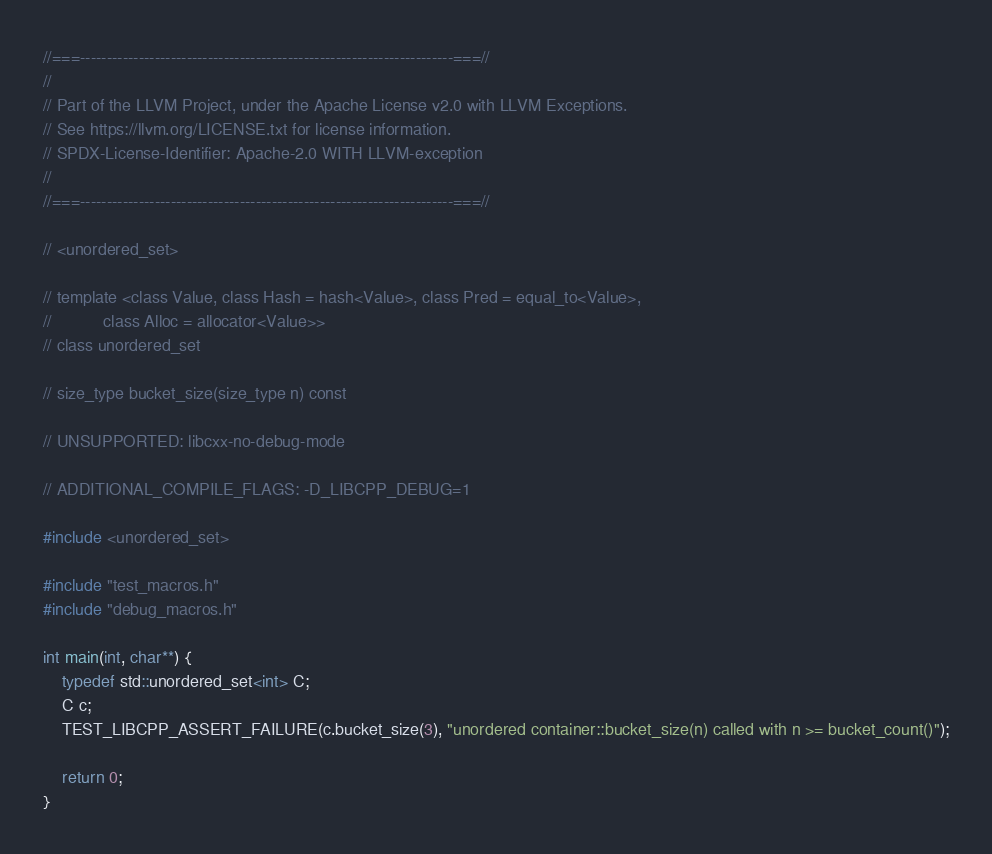<code> <loc_0><loc_0><loc_500><loc_500><_C++_>//===----------------------------------------------------------------------===//
//
// Part of the LLVM Project, under the Apache License v2.0 with LLVM Exceptions.
// See https://llvm.org/LICENSE.txt for license information.
// SPDX-License-Identifier: Apache-2.0 WITH LLVM-exception
//
//===----------------------------------------------------------------------===//

// <unordered_set>

// template <class Value, class Hash = hash<Value>, class Pred = equal_to<Value>,
//           class Alloc = allocator<Value>>
// class unordered_set

// size_type bucket_size(size_type n) const

// UNSUPPORTED: libcxx-no-debug-mode

// ADDITIONAL_COMPILE_FLAGS: -D_LIBCPP_DEBUG=1

#include <unordered_set>

#include "test_macros.h"
#include "debug_macros.h"

int main(int, char**) {
    typedef std::unordered_set<int> C;
    C c;
    TEST_LIBCPP_ASSERT_FAILURE(c.bucket_size(3), "unordered container::bucket_size(n) called with n >= bucket_count()");

    return 0;
}
</code> 